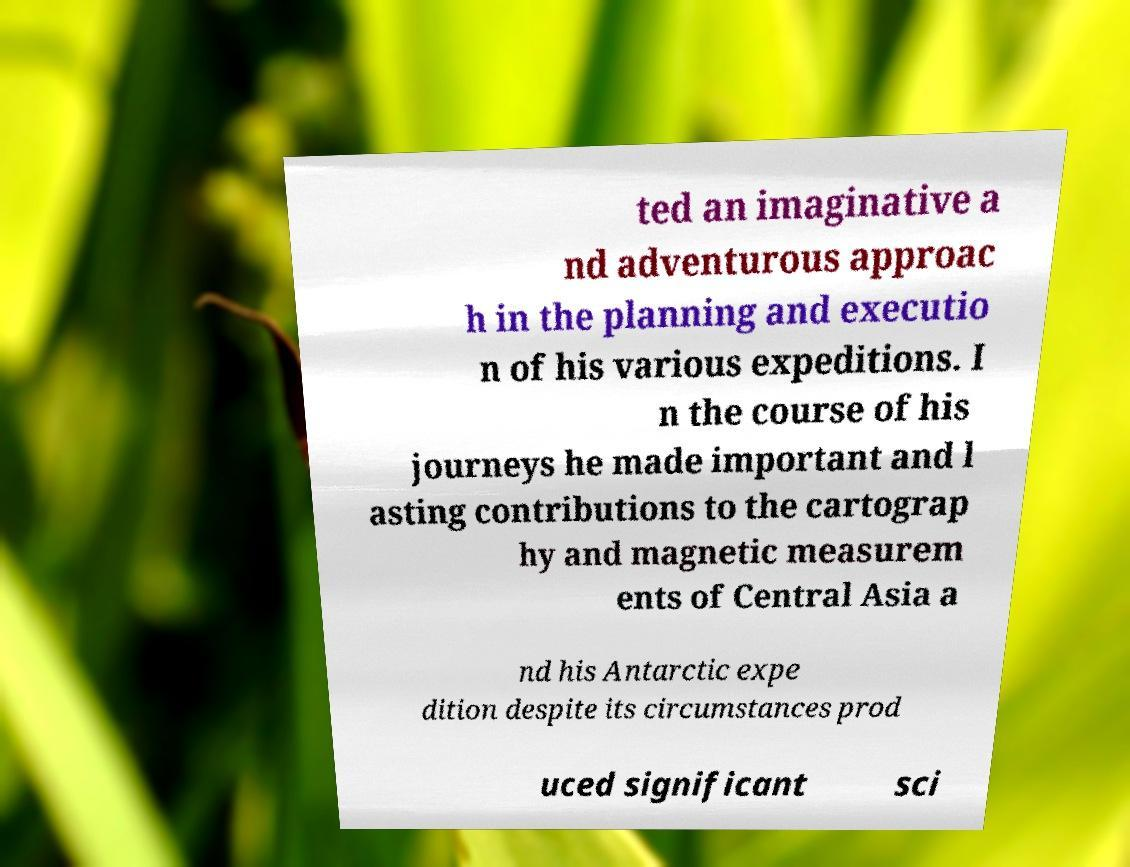Can you read and provide the text displayed in the image?This photo seems to have some interesting text. Can you extract and type it out for me? ted an imaginative a nd adventurous approac h in the planning and executio n of his various expeditions. I n the course of his journeys he made important and l asting contributions to the cartograp hy and magnetic measurem ents of Central Asia a nd his Antarctic expe dition despite its circumstances prod uced significant sci 